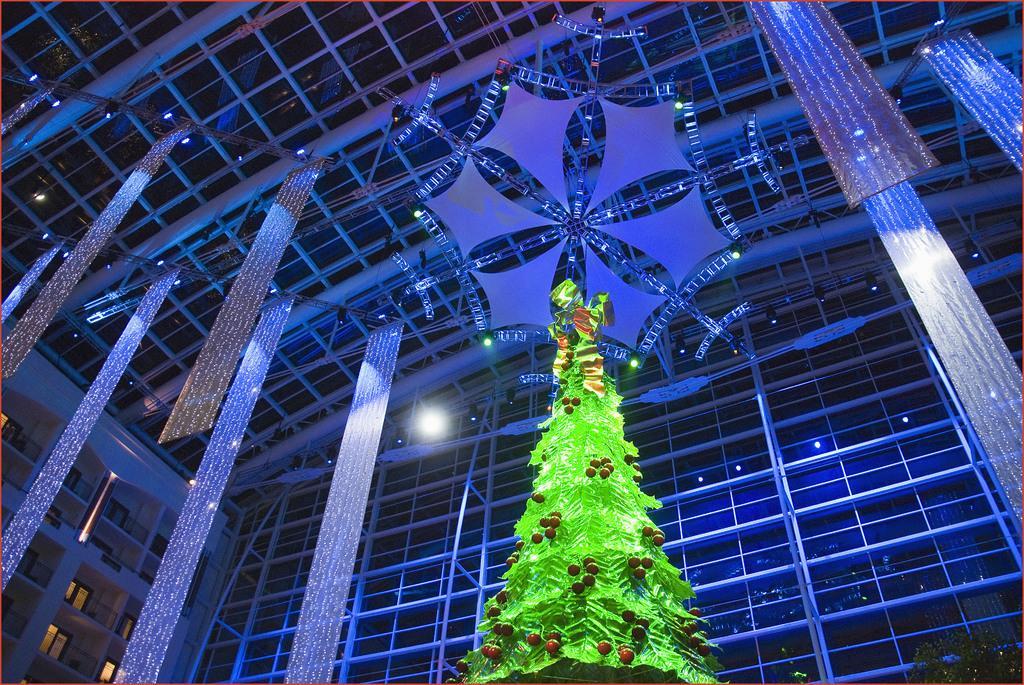Can you describe this image briefly? There is a Christmas tree as we can see in the middle of this image. There is a glass wall and a roof in the background. 